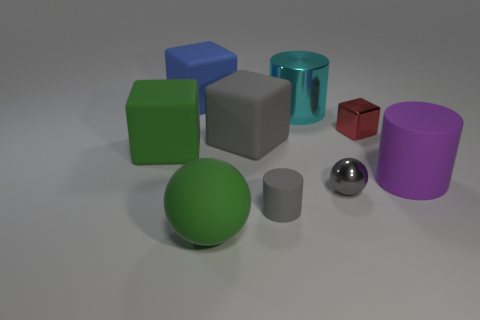How many large rubber spheres have the same color as the small matte thing?
Your answer should be very brief. 0. What number of small things are blue matte cubes or cyan rubber cylinders?
Your answer should be compact. 0. There is a metallic object that is the same color as the tiny rubber object; what is its size?
Your answer should be very brief. Small. Are there any red blocks that have the same material as the big blue block?
Keep it short and to the point. No. There is a large thing that is in front of the tiny gray matte cylinder; what material is it?
Your answer should be compact. Rubber. Does the big rubber object that is right of the gray cylinder have the same color as the matte cylinder on the left side of the large purple rubber object?
Offer a very short reply. No. There is a cylinder that is the same size as the gray metallic thing; what color is it?
Give a very brief answer. Gray. What number of other things are there of the same shape as the tiny gray matte thing?
Your answer should be compact. 2. There is a sphere behind the large rubber ball; how big is it?
Your response must be concise. Small. How many matte cylinders are in front of the big green object on the left side of the green sphere?
Provide a short and direct response. 2. 